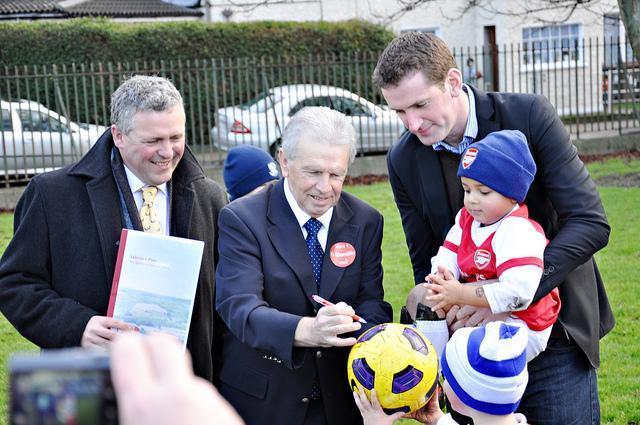How many people can you see?
Give a very brief answer. 7. How many cars are in the photo?
Give a very brief answer. 2. 